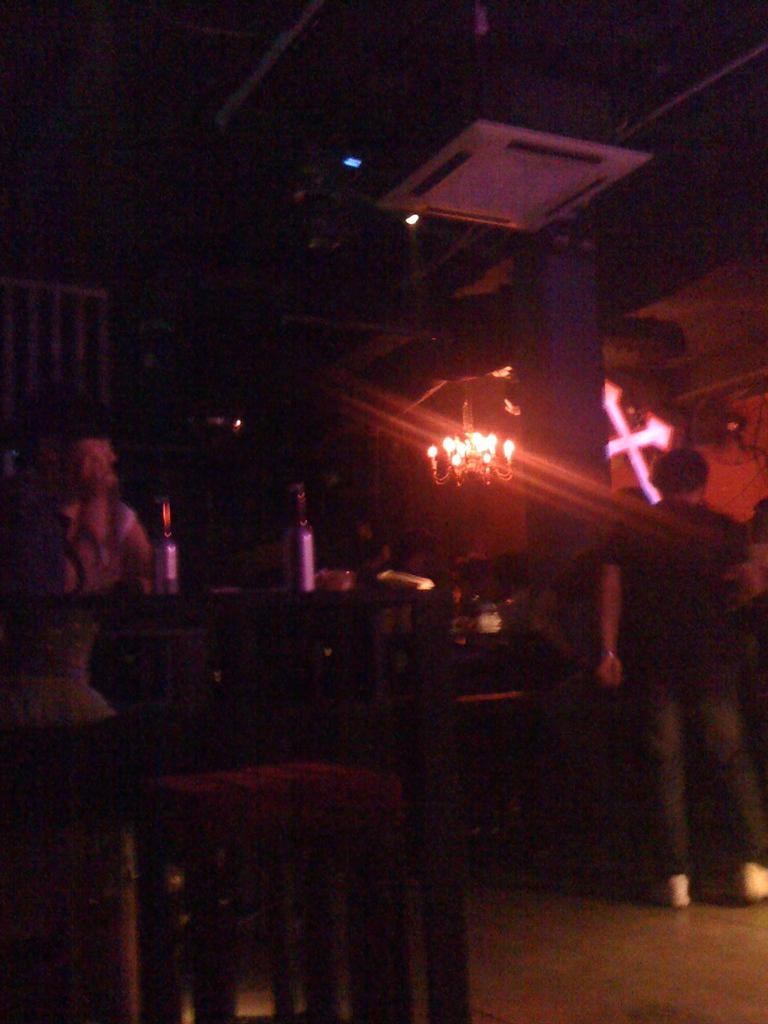How many people are in the image? There is a group of people in the image. What objects can be seen in the image besides the people? There are bottles, chairs, a holy cross, a chandelier, and a cassette air conditioner in the image. What type of furniture is present in the image? Chairs are present in the image. What type of lighting fixture is in the image? There is a chandelier in the image. What type of dirt can be seen on the tooth in the image? There is no tooth or dirt present in the image. What type of thrill can be experienced by the people in the image? The image does not provide information about the emotions or experiences of the people, so it cannot be determined if they are experiencing any thrill. 